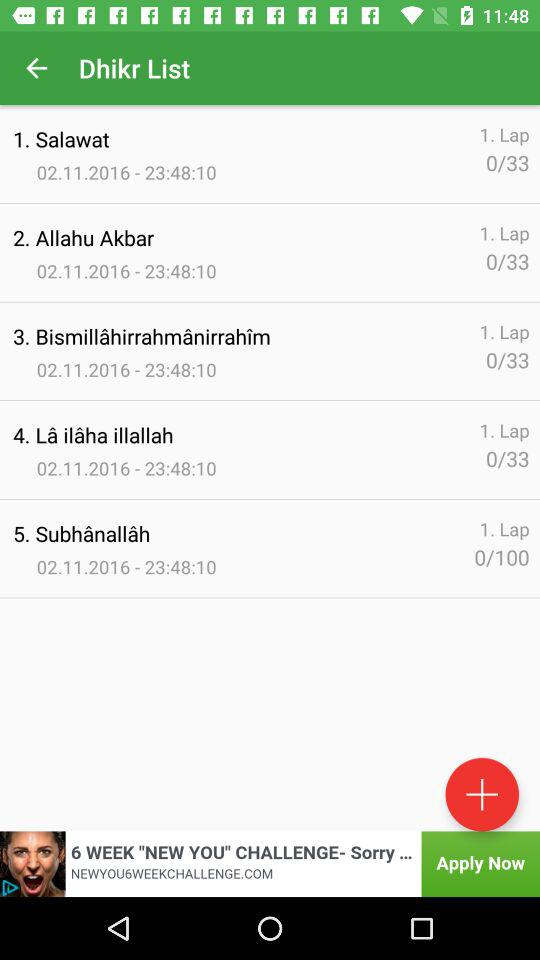How are items added to the list?
When the provided information is insufficient, respond with <no answer>. <no answer> 